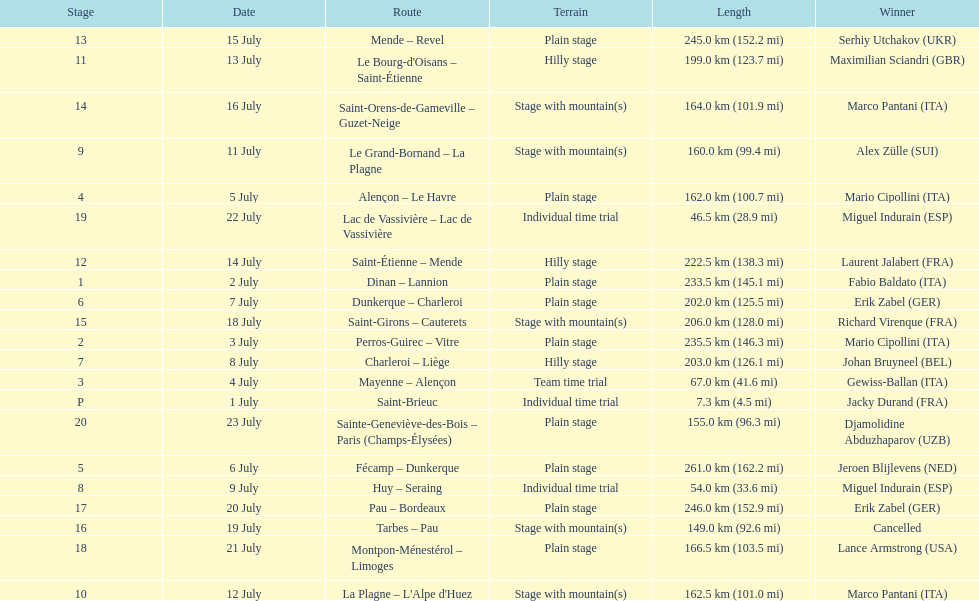Which routes were at least 100 km? Dinan - Lannion, Perros-Guirec - Vitre, Alençon - Le Havre, Fécamp - Dunkerque, Dunkerque - Charleroi, Charleroi - Liège, Le Grand-Bornand - La Plagne, La Plagne - L'Alpe d'Huez, Le Bourg-d'Oisans - Saint-Étienne, Saint-Étienne - Mende, Mende - Revel, Saint-Orens-de-Gameville - Guzet-Neige, Saint-Girons - Cauterets, Tarbes - Pau, Pau - Bordeaux, Montpon-Ménestérol - Limoges, Sainte-Geneviève-des-Bois - Paris (Champs-Élysées). 